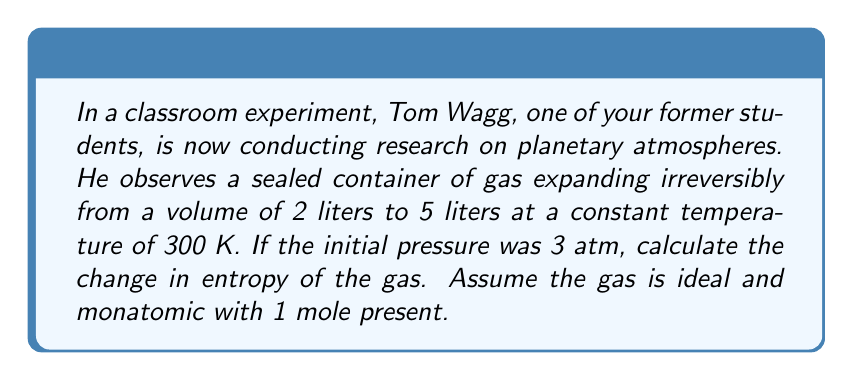Provide a solution to this math problem. Let's approach this step-by-step:

1) For an irreversible process, we can calculate the entropy change using the equation:

   $$\Delta S = nR \ln(\frac{V_f}{V_i})$$

   where $n$ is the number of moles, $R$ is the gas constant, $V_f$ is the final volume, and $V_i$ is the initial volume.

2) We're given:
   - $n = 1$ mole
   - $V_i = 2$ liters
   - $V_f = 5$ liters
   - $R = 8.314$ J/(mol·K)

3) Substituting these values into the equation:

   $$\Delta S = (1 \text{ mol})(8.314 \text{ J/(mol·K)}) \ln(\frac{5 \text{ L}}{2 \text{ L}})$$

4) Simplify:
   $$\Delta S = 8.314 \text{ J/K} \cdot \ln(2.5)$$

5) Calculate:
   $$\Delta S = 8.314 \text{ J/K} \cdot 0.9163 = 7.618 \text{ J/K}$$

Note: The initial pressure and temperature, while given, are not needed for this calculation as the entropy change for an ideal gas in an isothermal process depends only on the volume change.
Answer: 7.618 J/K 